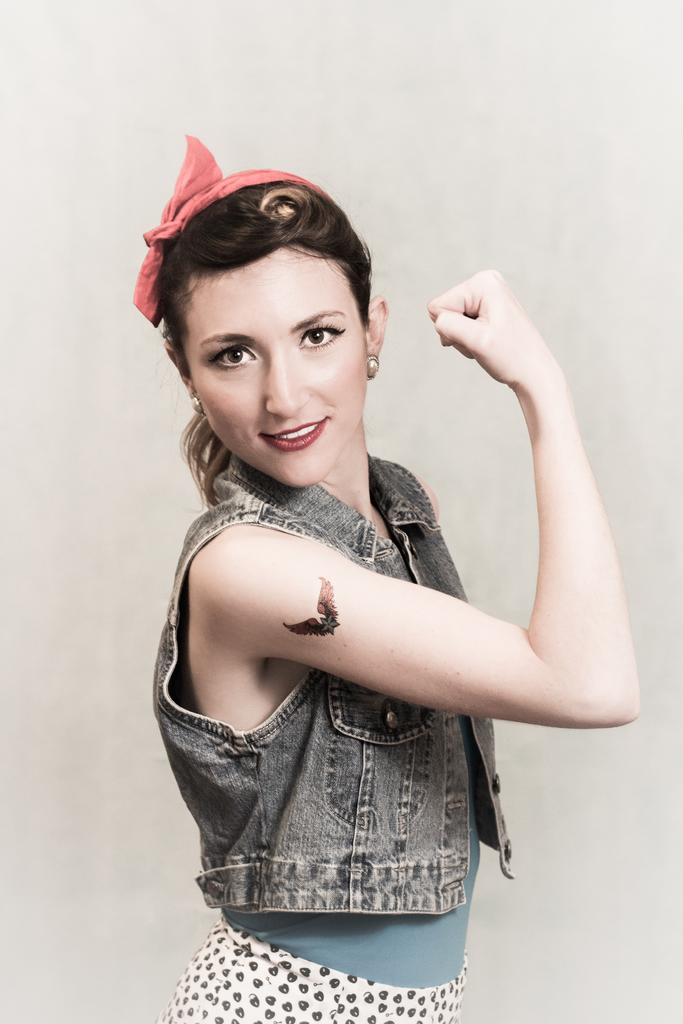Who is present in the image? There is a woman in the image. What is the woman doing in the image? The woman is smiling. Can you describe any distinguishing features of the woman? The woman has a tattoo on her hand. What is the color of the background in the image? The background of the image is white. What date is circled on the calendar in the image? There is no calendar present in the image. Can you tell me how to join the club depicted in the image? There is no club depicted in the image. 